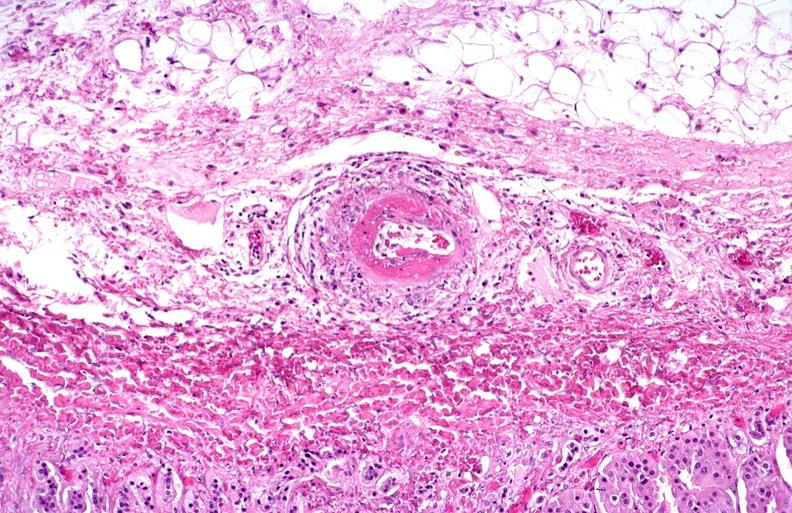does aorta show polyarteritis nodosa?
Answer the question using a single word or phrase. No 